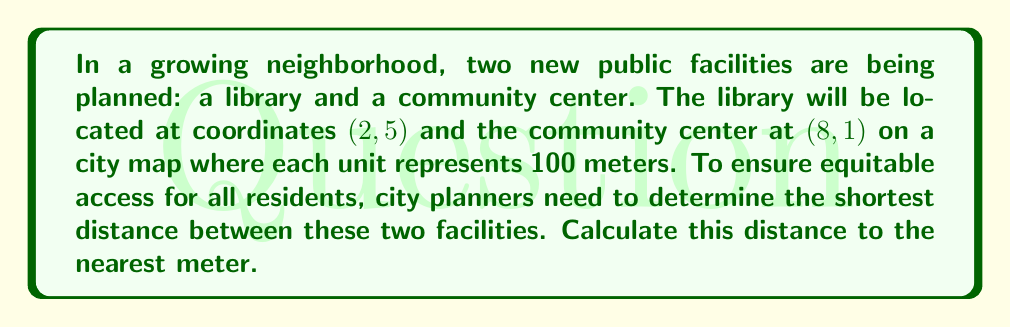Could you help me with this problem? To find the shortest distance between two points in a plane, we can use the distance formula, which is derived from the Pythagorean theorem. Let's follow these steps:

1) The distance formula is:
   $$d = \sqrt{(x_2 - x_1)^2 + (y_2 - y_1)^2}$$
   where $(x_1, y_1)$ and $(x_2, y_2)$ are the coordinates of the two points.

2) In this case:
   Library: $(x_1, y_1) = (2, 5)$
   Community center: $(x_2, y_2) = (8, 1)$

3) Let's substitute these values into the formula:
   $$d = \sqrt{(8 - 2)^2 + (1 - 5)^2}$$

4) Simplify inside the parentheses:
   $$d = \sqrt{6^2 + (-4)^2}$$

5) Calculate the squares:
   $$d = \sqrt{36 + 16}$$

6) Add inside the square root:
   $$d = \sqrt{52}$$

7) Simplify the square root:
   $$d = 2\sqrt{13}$$

8) This gives us the distance in units. To convert to meters, multiply by 100:
   $$d = 200\sqrt{13} \approx 721.11 \text{ meters}$$

9) Rounding to the nearest meter:
   $$d \approx 721 \text{ meters}$$

[asy]
unitsize(1cm);
dotfactor = 4;
dot((2,5));
dot((8,1));
draw((2,5)--(8,1), arrow=Arrow(TeXHead));
label("Library (2, 5)", (2,5), N);
label("Community Center (8, 1)", (8,1), S);
label("721 m", (5,3), SE);
[/asy]
Answer: 721 meters 